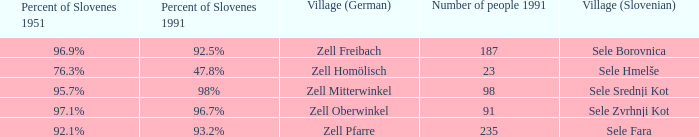Provide me with the name of all the village (German) that are part of the village (Slovenian) with sele srednji kot.  Zell Mitterwinkel. 